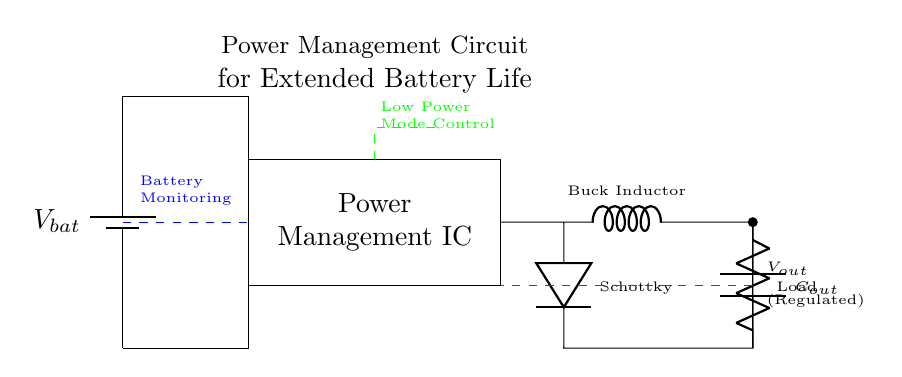What type of circuit is this? This is a power management circuit specifically designed for managing battery usage in mobile devices to extend battery life. The presence of a power management IC and components like a buck converter and load indicate its purpose in voltage regulation and power optimization.
Answer: Power management circuit What component regulates the output voltage? The component that regulates the output voltage is the power management integrated circuit (PMIC). This component is responsible for controlling the flow of energy and maintaining a stable output voltage.
Answer: Power Management IC Which component is responsible for ensuring the battery's longevity? The battery monitoring section of the circuit, indicated by the blue dashed line, is responsible for monitoring the battery's state, which helps in managing its longevity by preventing overcharging or deep discharging.
Answer: Battery Monitoring What does the dashed red line represent? The dashed red line represents the feedback loop that is used to monitor and adjust the output voltage according to the load requirements, which is essential for maintaining stable performance as the load changes.
Answer: Feedback What type of converter is used in this circuit? A buck converter is used in this circuit, which steps down a higher input voltage to a lower output voltage, making it ideal for efficient power management in mobile devices.
Answer: Buck Converter What is the purpose of the output capacitor in the circuit? The output capacitor stores energy and smooths out voltage fluctuations at the output of the buck converter, thus ensuring a stable voltage supply to the load during operation.
Answer: Improve stability What control feature is indicated by the green dashed line? The green dashed line indicates the low power mode control, which allows the device to switch to a lower power consumption state to extend battery life during less demanding operations.
Answer: Low Power Mode Control 